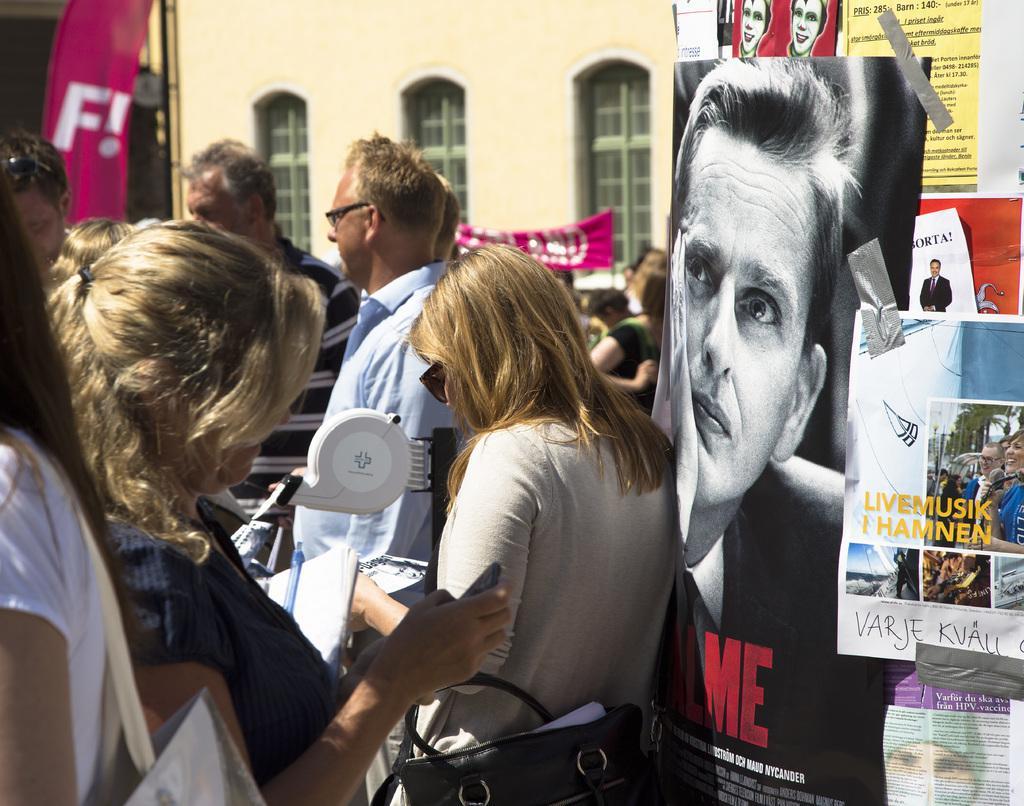Can you describe this image briefly? In this picture we can see some people are standing, a woman in the front is holding a mobile phone, a woman on the right side is carrying a bag, there are some posters pasted on the right side, in the background there is a building, we can see a banner in the middle. 